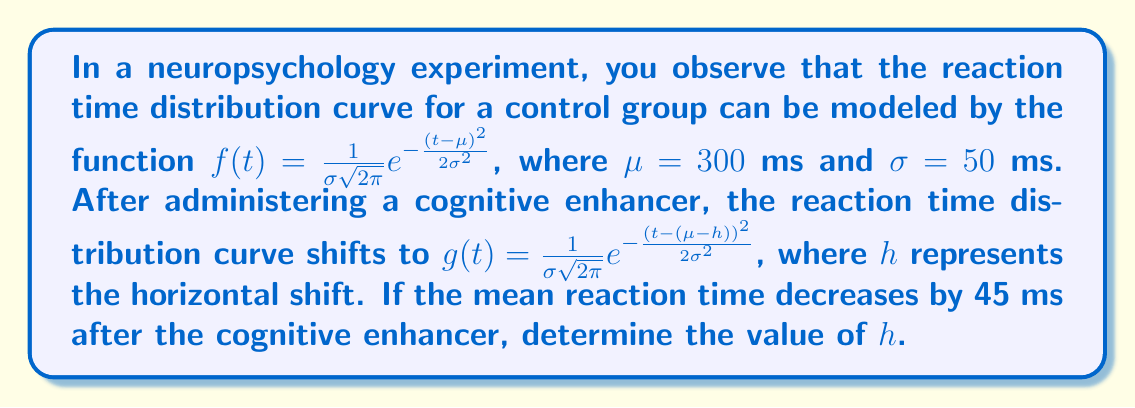Could you help me with this problem? To solve this problem, we'll follow these steps:

1) The original function $f(t)$ has a mean (center) at $\mu = 300$ ms.

2) The new function $g(t)$ has shifted horizontally by $h$ units to the left, which means its center is at $\mu - h$.

3) We're told that the mean reaction time has decreased by 45 ms. This means:

   $(\mu - h) = 300 - 45 = 255$ ms

4) Now we can set up an equation:

   $\mu - h = 255$

5) Substituting the known value of $\mu$:

   $300 - h = 255$

6) Solving for $h$:

   $-h = 255 - 300$
   $-h = -45$
   $h = 45$

Therefore, the horizontal shift $h$ is 45 ms to the left.
Answer: $h = 45$ ms 